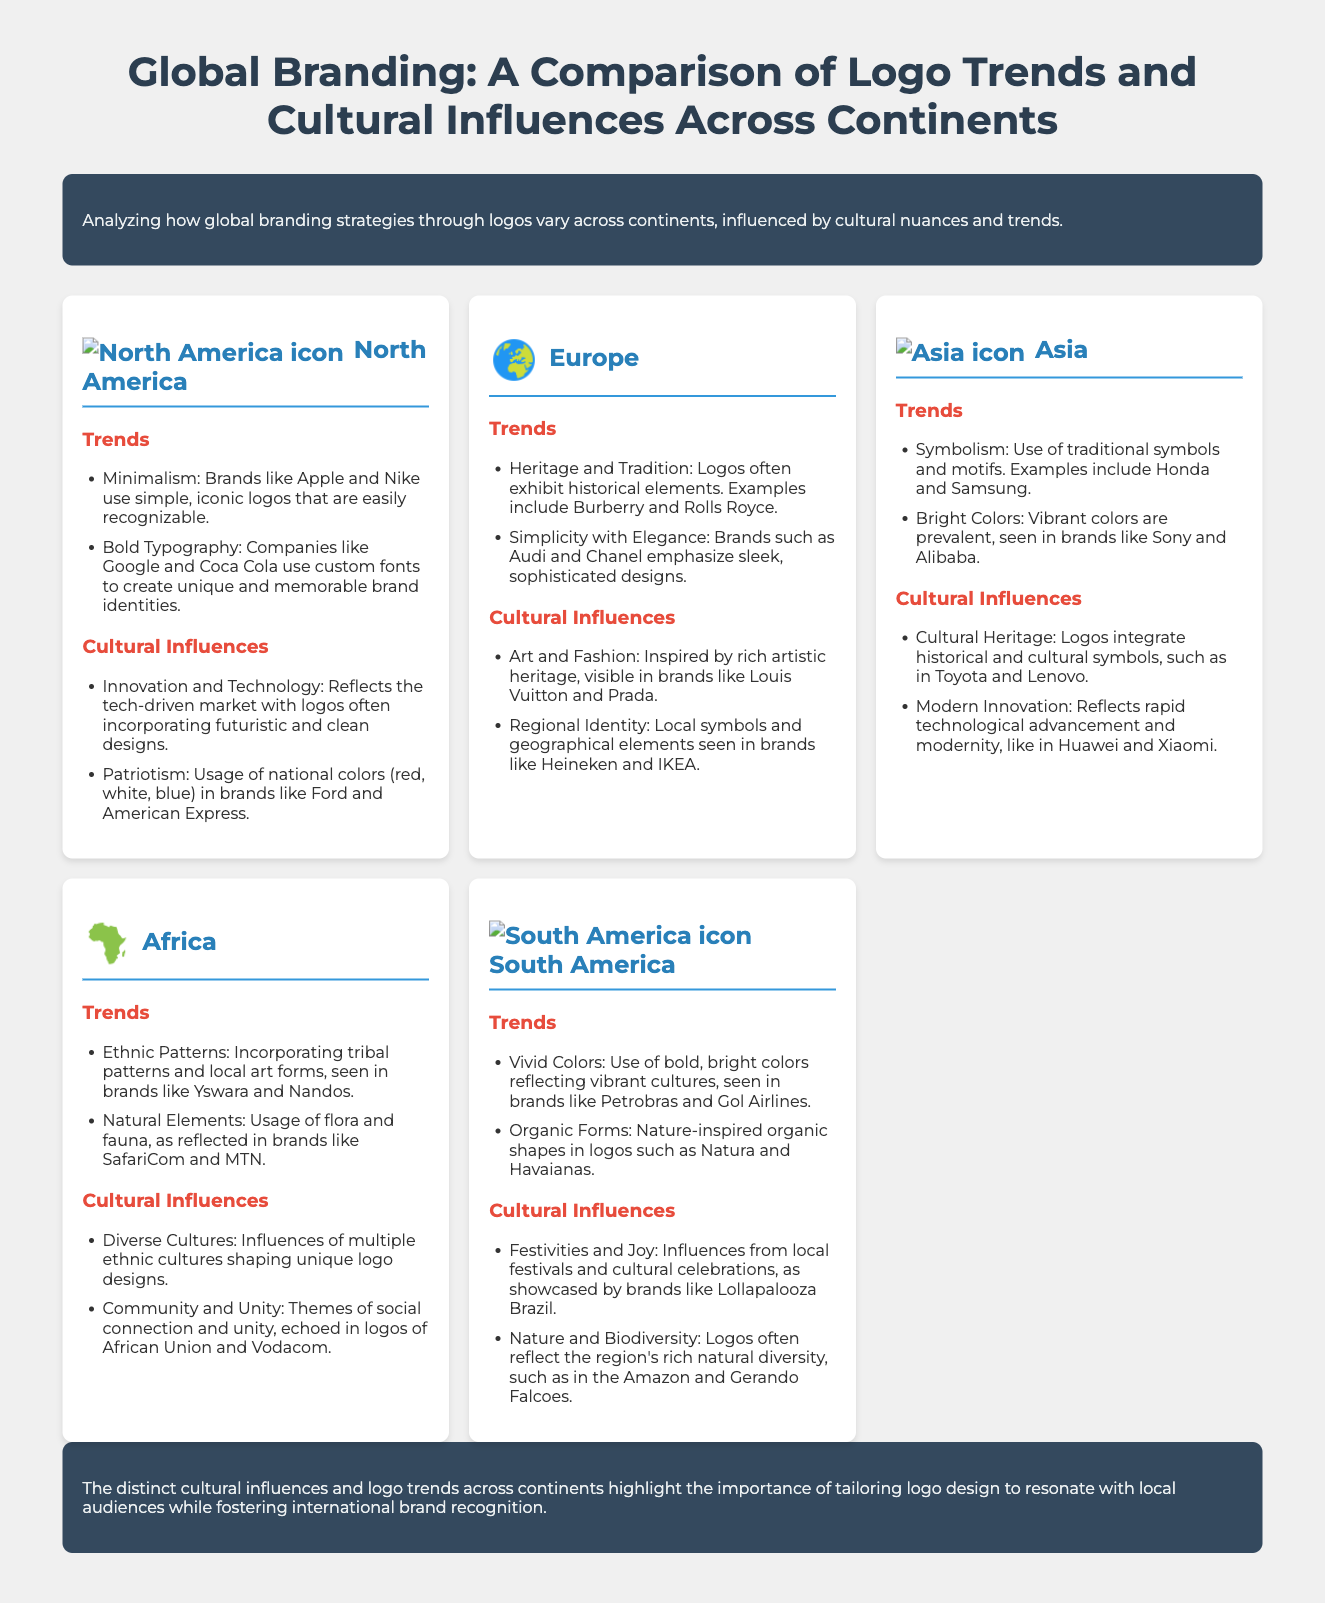What are the logo trends in North America? The document lists minimalism and bold typography as the logo trends in North America.
Answer: Minimalism, Bold Typography Which brand is associated with the trend of heritage and tradition in Europe? The document mentions Burberry as an example of a brand that exhibits heritage and tradition in its logo.
Answer: Burberry What is a common color theme used in North American logos? The document states that patriotism reflects in the usage of national colors like red, white, and blue.
Answer: Red, White, Blue Which continent emphasizes ethnic patterns in logo design? The document specifically mentions Africa as incorporating ethnic patterns into logo designs.
Answer: Africa What do vibrant colors in South American logos reflect? The document indicates that vivid colors reflect vibrant cultures within South America.
Answer: Vibrant cultures What are two cultural influences mentioned for Asia? The document lists cultural heritage and modern innovation as cultural influences in Asia.
Answer: Cultural Heritage, Modern Innovation Which logo trend is highlighted in Africa? The document identifies ethnic patterns as a significant trend in African logo design.
Answer: Ethnic Patterns What distinguishes European logos according to the trends mentioned? The document notes simplicity with elegance as a distinguishing feature of European logos.
Answer: Simplicity with Elegance What is the conclusion regarding logo design across continents? The document concludes that logos must resonate with local audiences while building international brand recognition.
Answer: Tailoring to local audiences 